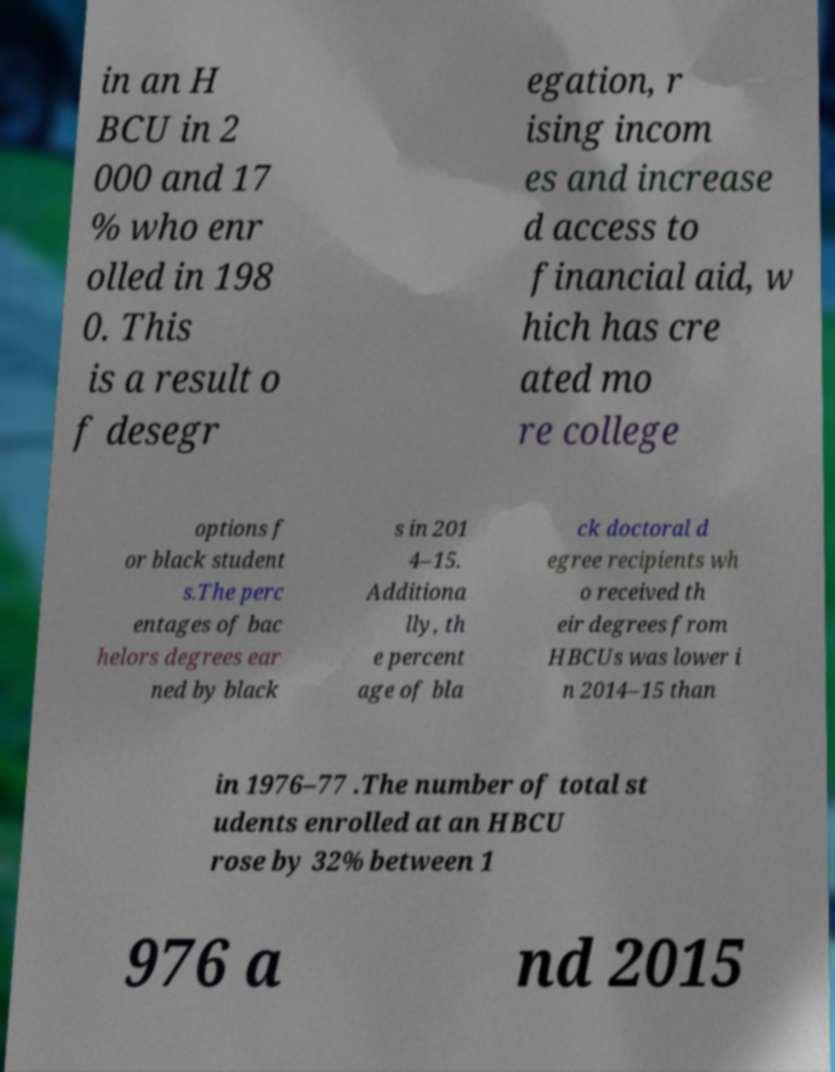Could you assist in decoding the text presented in this image and type it out clearly? in an H BCU in 2 000 and 17 % who enr olled in 198 0. This is a result o f desegr egation, r ising incom es and increase d access to financial aid, w hich has cre ated mo re college options f or black student s.The perc entages of bac helors degrees ear ned by black s in 201 4–15. Additiona lly, th e percent age of bla ck doctoral d egree recipients wh o received th eir degrees from HBCUs was lower i n 2014–15 than in 1976–77 .The number of total st udents enrolled at an HBCU rose by 32% between 1 976 a nd 2015 